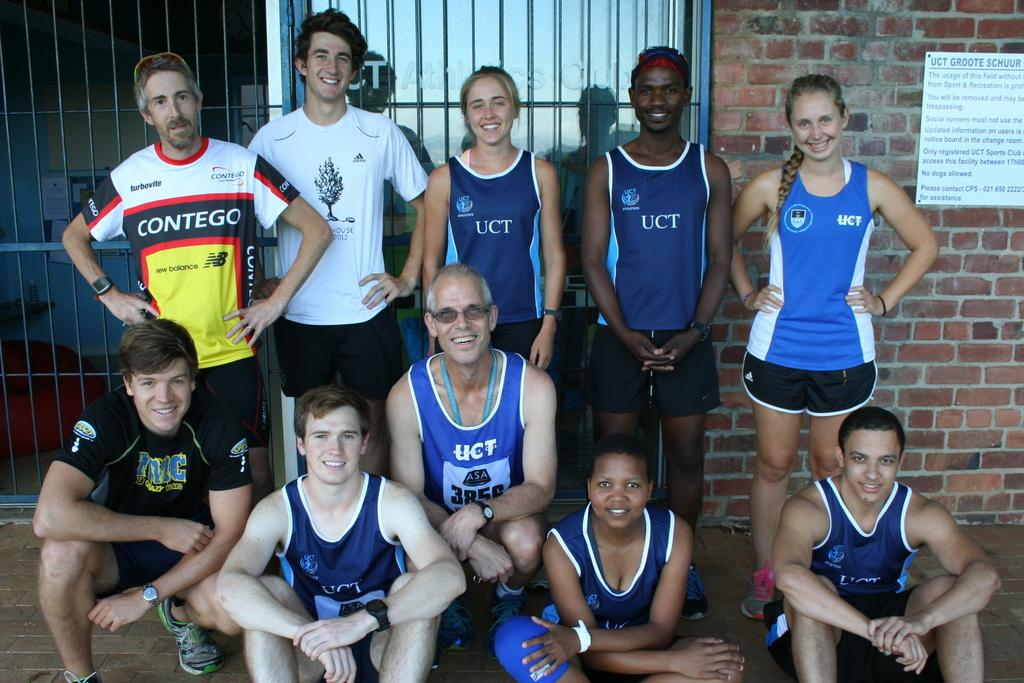<image>
Give a short and clear explanation of the subsequent image. a few people that have the word UCT on their outfits 